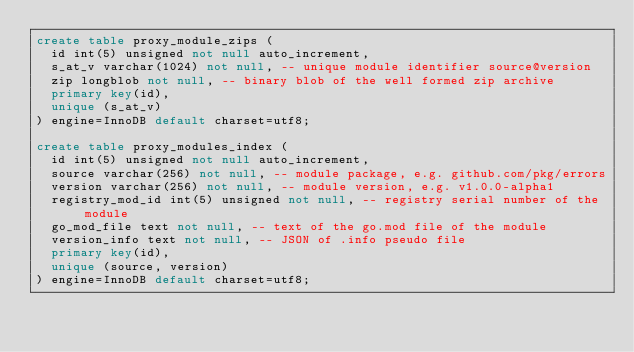<code> <loc_0><loc_0><loc_500><loc_500><_SQL_>create table proxy_module_zips (
  id int(5) unsigned not null auto_increment,
  s_at_v varchar(1024) not null, -- unique module identifier source@version
  zip longblob not null, -- binary blob of the well formed zip archive
  primary key(id),
  unique (s_at_v)
) engine=InnoDB default charset=utf8;

create table proxy_modules_index (
  id int(5) unsigned not null auto_increment,
  source varchar(256) not null, -- module package, e.g. github.com/pkg/errors
  version varchar(256) not null, -- module version, e.g. v1.0.0-alpha1
  registry_mod_id int(5) unsigned not null, -- registry serial number of the module
  go_mod_file text not null, -- text of the go.mod file of the module
  version_info text not null, -- JSON of .info pseudo file
  primary key(id),
  unique (source, version)
) engine=InnoDB default charset=utf8;
</code> 